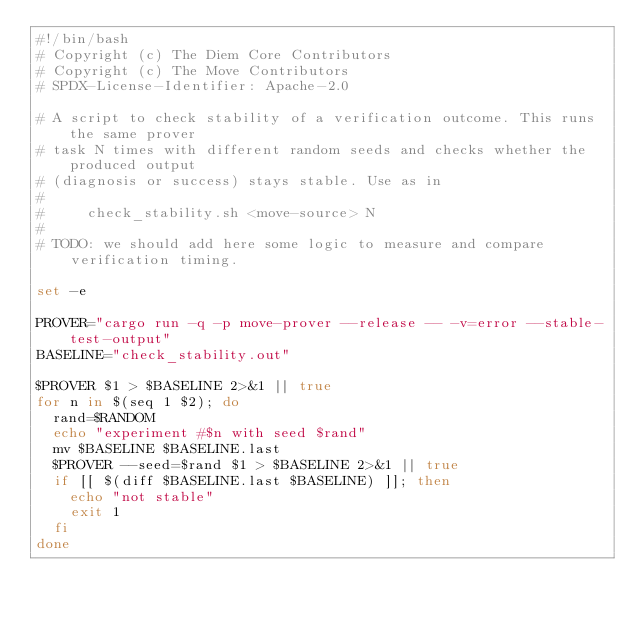<code> <loc_0><loc_0><loc_500><loc_500><_Bash_>#!/bin/bash
# Copyright (c) The Diem Core Contributors
# Copyright (c) The Move Contributors
# SPDX-License-Identifier: Apache-2.0

# A script to check stability of a verification outcome. This runs the same prover
# task N times with different random seeds and checks whether the produced output
# (diagnosis or success) stays stable. Use as in
#
#     check_stability.sh <move-source> N
#
# TODO: we should add here some logic to measure and compare verification timing.

set -e

PROVER="cargo run -q -p move-prover --release -- -v=error --stable-test-output"
BASELINE="check_stability.out"

$PROVER $1 > $BASELINE 2>&1 || true
for n in $(seq 1 $2); do
  rand=$RANDOM
  echo "experiment #$n with seed $rand"
  mv $BASELINE $BASELINE.last
  $PROVER --seed=$rand $1 > $BASELINE 2>&1 || true
  if [[ $(diff $BASELINE.last $BASELINE) ]]; then
    echo "not stable"
    exit 1
  fi
done
</code> 